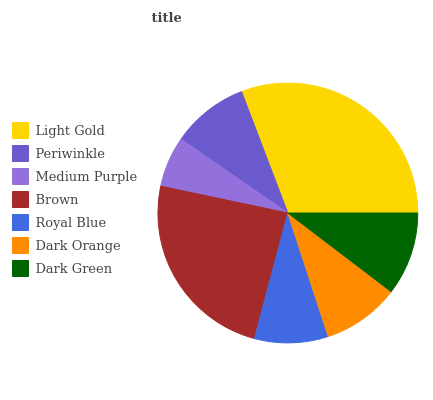Is Medium Purple the minimum?
Answer yes or no. Yes. Is Light Gold the maximum?
Answer yes or no. Yes. Is Periwinkle the minimum?
Answer yes or no. No. Is Periwinkle the maximum?
Answer yes or no. No. Is Light Gold greater than Periwinkle?
Answer yes or no. Yes. Is Periwinkle less than Light Gold?
Answer yes or no. Yes. Is Periwinkle greater than Light Gold?
Answer yes or no. No. Is Light Gold less than Periwinkle?
Answer yes or no. No. Is Dark Orange the high median?
Answer yes or no. Yes. Is Dark Orange the low median?
Answer yes or no. Yes. Is Periwinkle the high median?
Answer yes or no. No. Is Dark Green the low median?
Answer yes or no. No. 